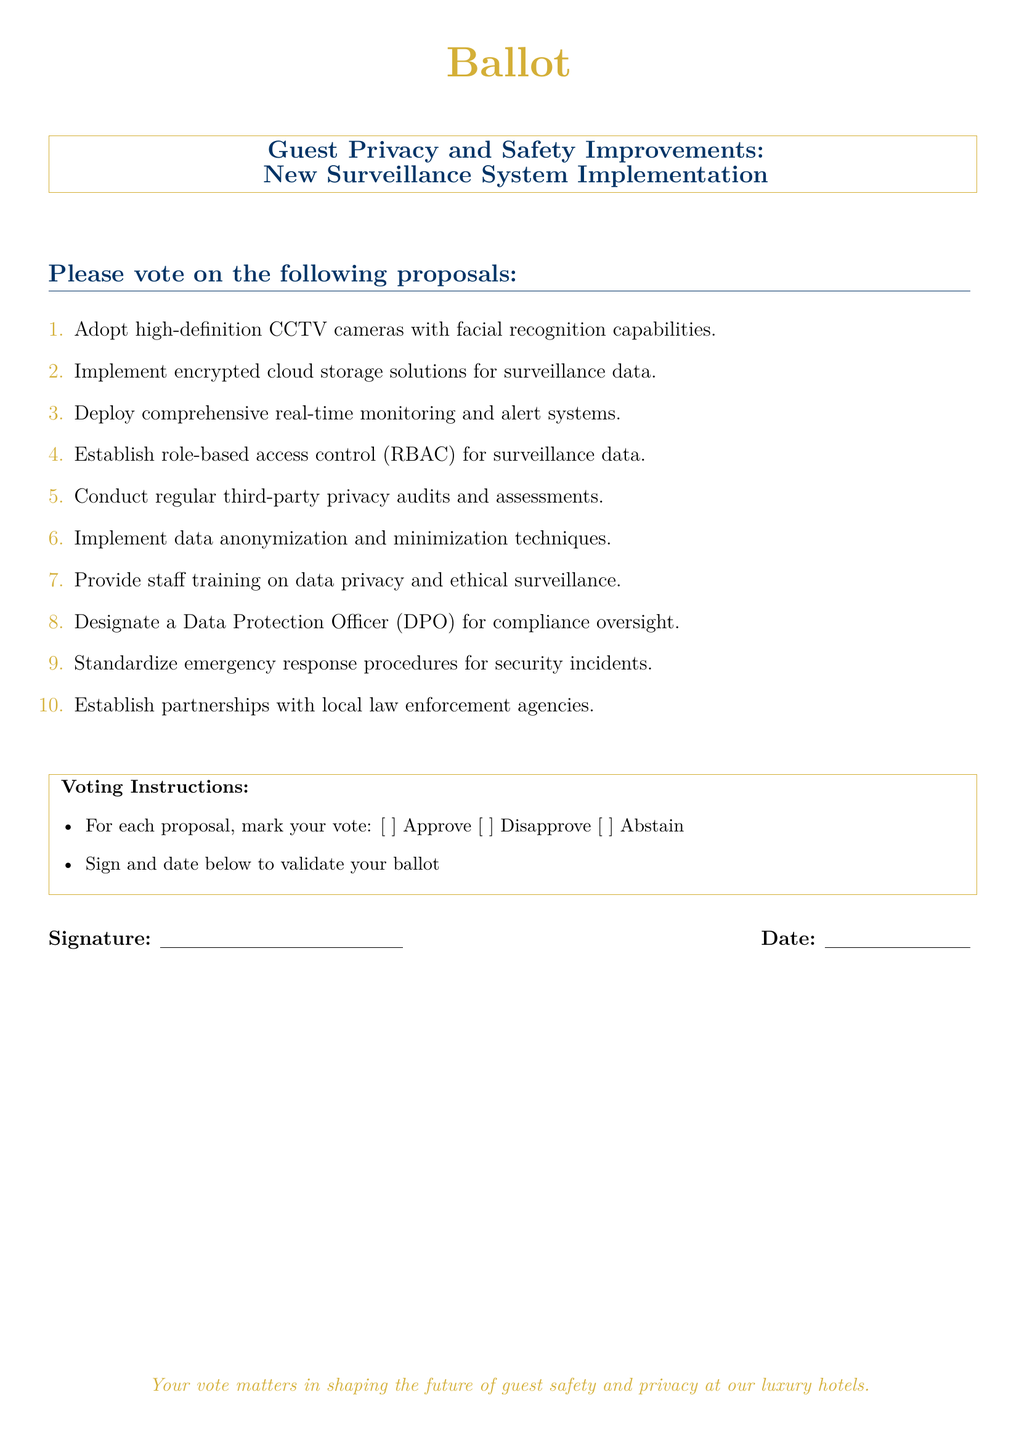What is the main topic of the ballot? The main topic is focused on improvements related to guest privacy and safety in the context of a new surveillance system implementation.
Answer: Guest Privacy and Safety Improvements How many proposals are listed in the ballot? The ballot contains a total of ten proposals for consideration.
Answer: 10 What is proposal number 4 about? Proposal number 4 refers to the establishment of controlled access to surveillance data based on roles within the organization.
Answer: Role-based access control (RBAC) Who should be designated according to proposal number 8? Proposal number 8 suggests the appointment of an individual responsible for overseeing compliance with data protection regulations.
Answer: Data Protection Officer (DPO) What should the staff receive training on according to proposal number 7? Proposal number 7 emphasizes the importance of educating staff on maintaining guest privacy and the ethical use of surveillance technologies.
Answer: Data privacy and ethical surveillance What do the voting instructions require for each proposal? The instructions specify that participants need to indicate their approval status for each proposal using a marking system.
Answer: Mark your vote What color is used for the heading of the ballot? The heading of the ballot utilizes a specific shade of gold as a color for emphasis and branding.
Answer: Luxury gold What is needed for the ballot to be validated? The ballot requires the individual to provide their signature and date to confirm their participation in the voting process.
Answer: Signature and date What is the purpose of conducting regular third-party audits? The audits aim to ensure that privacy measures and practices remain effective and comply with external regulations or standards.
Answer: Privacy audits and assessments Which type of partnerships does proposal number 10 suggest establishing? Proposal number 10 recommends forming collaborations with local law enforcement to enhance safety measures within the hotels.
Answer: Local law enforcement agencies 